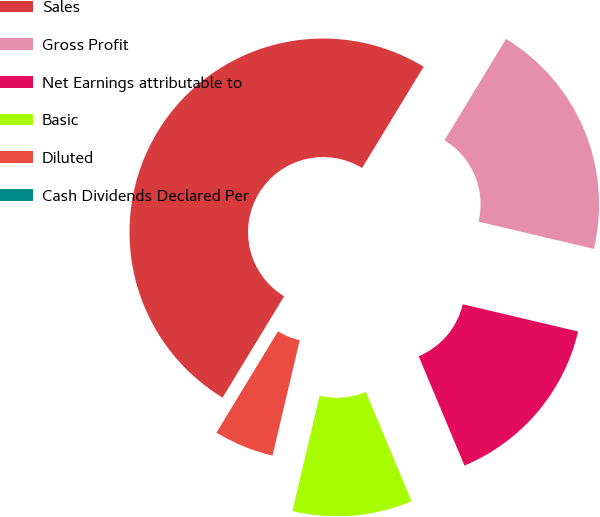Convert chart. <chart><loc_0><loc_0><loc_500><loc_500><pie_chart><fcel>Sales<fcel>Gross Profit<fcel>Net Earnings attributable to<fcel>Basic<fcel>Diluted<fcel>Cash Dividends Declared Per<nl><fcel>50.0%<fcel>20.0%<fcel>15.0%<fcel>10.0%<fcel>5.0%<fcel>0.0%<nl></chart> 